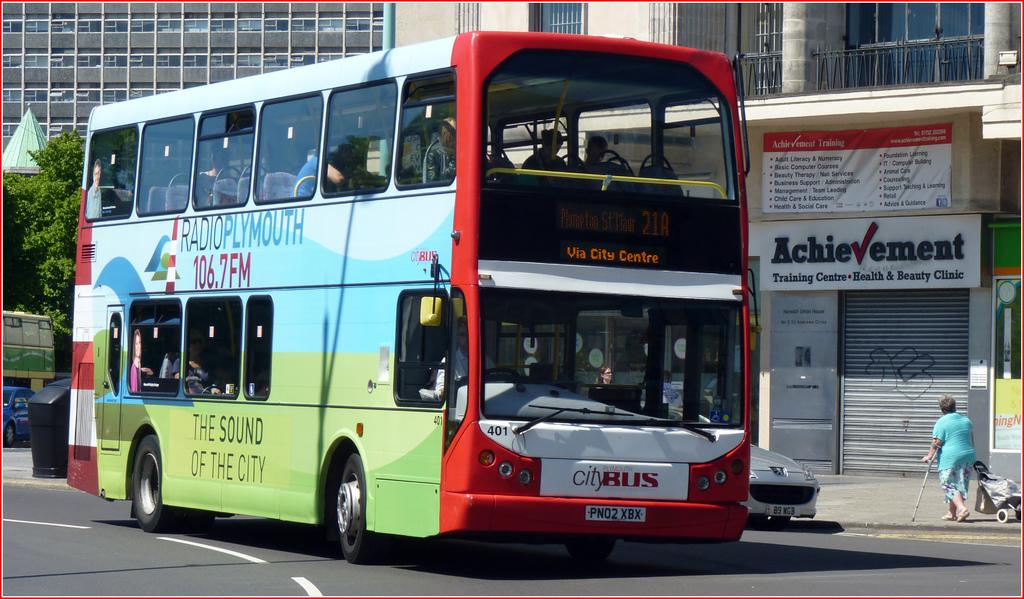<image>
Offer a succinct explanation of the picture presented. The double decker bus on the road has a billboard for 106.7 FM on its side. 